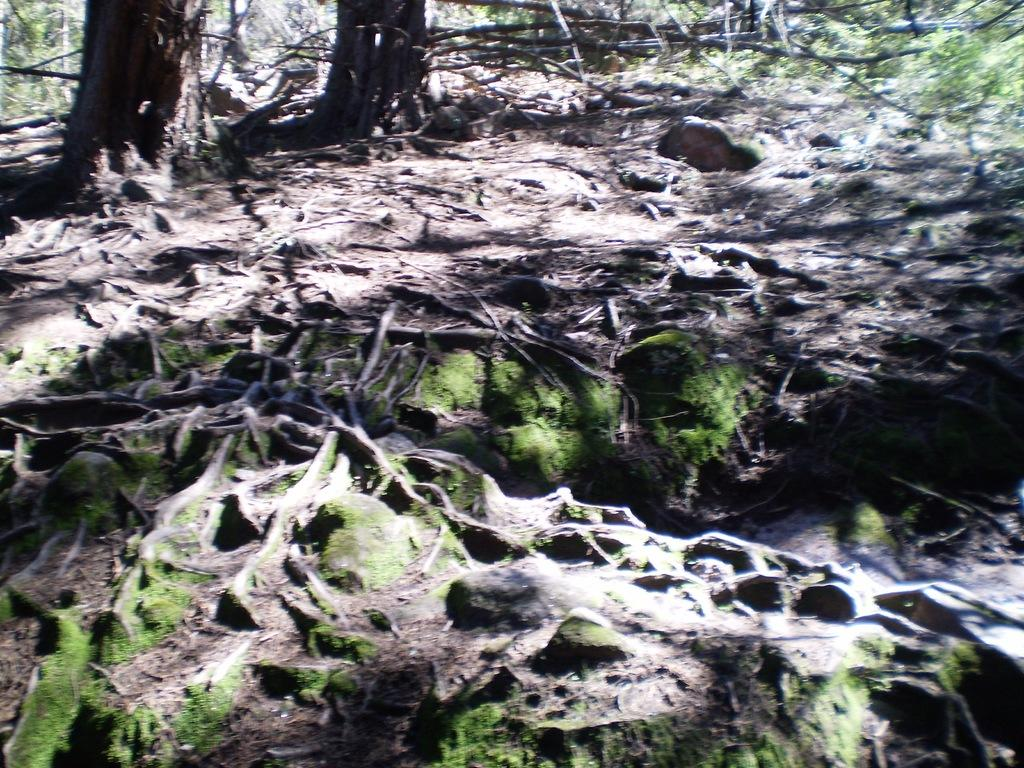What type of surface can be seen in the image? There is ground visible in the image. What type of plant life is present in the image? There is algae in the image. What can be seen in the background of the image? There are branches in the background of the image. What type of receipt can be seen in the image? There is no receipt present in the image. Can you compare the size of the algae to the branches in the image? It is not possible to compare the size of the algae to the branches in the image, as the facts provided do not give any information about their relative sizes. 